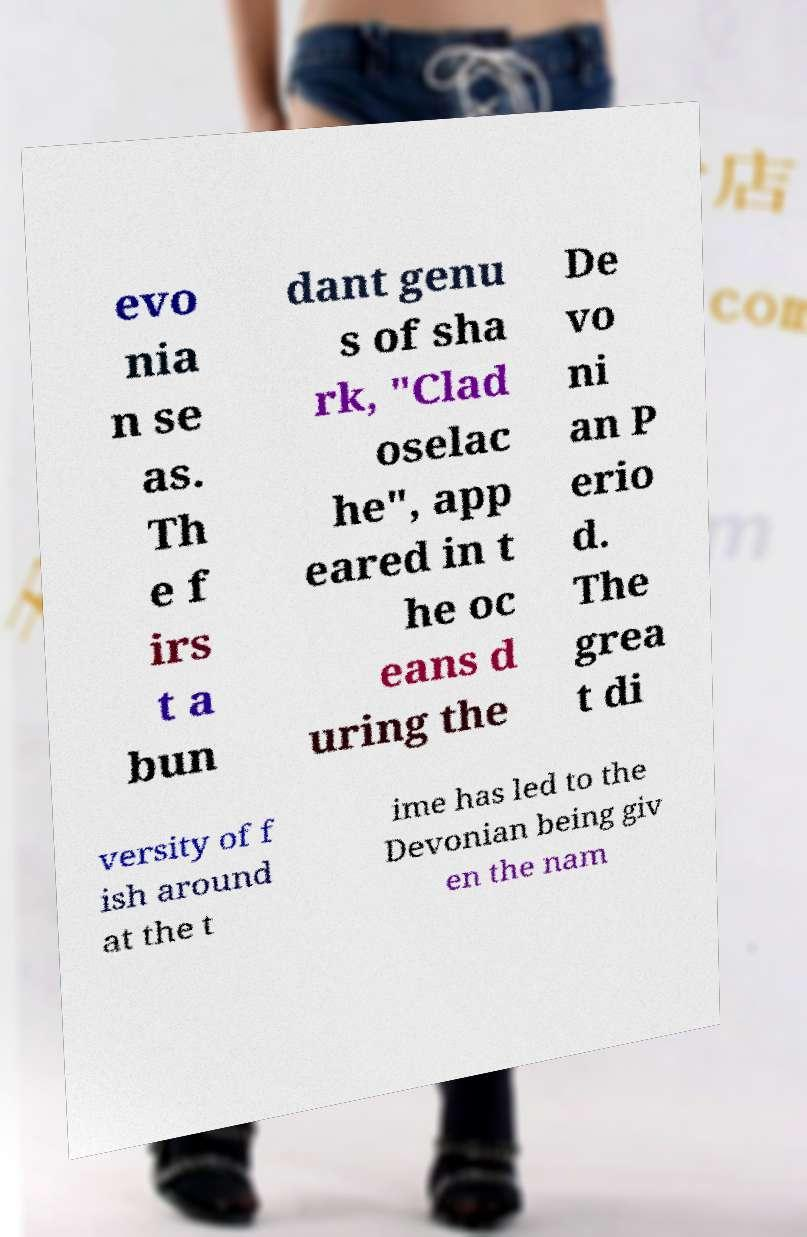For documentation purposes, I need the text within this image transcribed. Could you provide that? evo nia n se as. Th e f irs t a bun dant genu s of sha rk, "Clad oselac he", app eared in t he oc eans d uring the De vo ni an P erio d. The grea t di versity of f ish around at the t ime has led to the Devonian being giv en the nam 